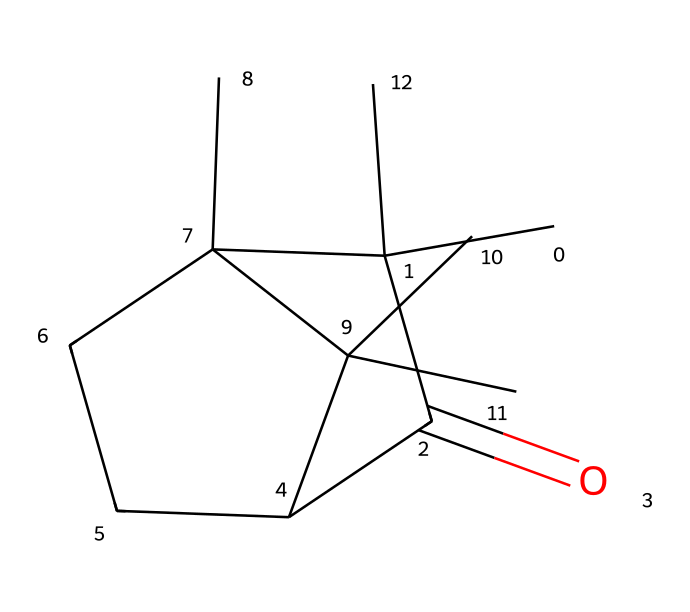How many carbon atoms are in camphor? By analyzing the SMILES representation, we can count the carbon atoms represented by "C" in the structure. The breakdown shows a total of 10 carbon atoms.
Answer: 10 What is the functional group present in camphor? The SMILES representation contains "C(=O)," which indicates a carbonyl functional group, specifically a ketone. This implies the presence of a carbonyl within the structure.
Answer: ketone What type of compound is camphor classified as? Given the ring structure and the presence of single and double bonds, camphor can be identified as a cyclic compound, specifically a cycloalkane due to its saturated nature and the carbon framework.
Answer: cycloalkane How many rings are present in the molecular structure of camphor? Inspection of the SMILES indicates that there are two ring structures, which can be deduced from the connected carbons forming closed loops. This can also be confirmed by the number of branching and saturation in the structure.
Answer: 2 What type of carbon hybridization is prevalent in camphor? Analyzing the carbon atoms in the structure shows that most of them are bonded in a tetrahedral manner, indicative of sp3 hybridization due to single bonds, while the carbon connected by a double bond exhibits sp2 hybridization. Thus, sp3 is the prevalent type.
Answer: sp3 Does camphor contain any heteroatoms? By checking the SMILES representation, we can see that it consists only of carbon and hydrogen atoms, with no other elements present in the formula, indicating it does not contain heteroatoms.
Answer: No 